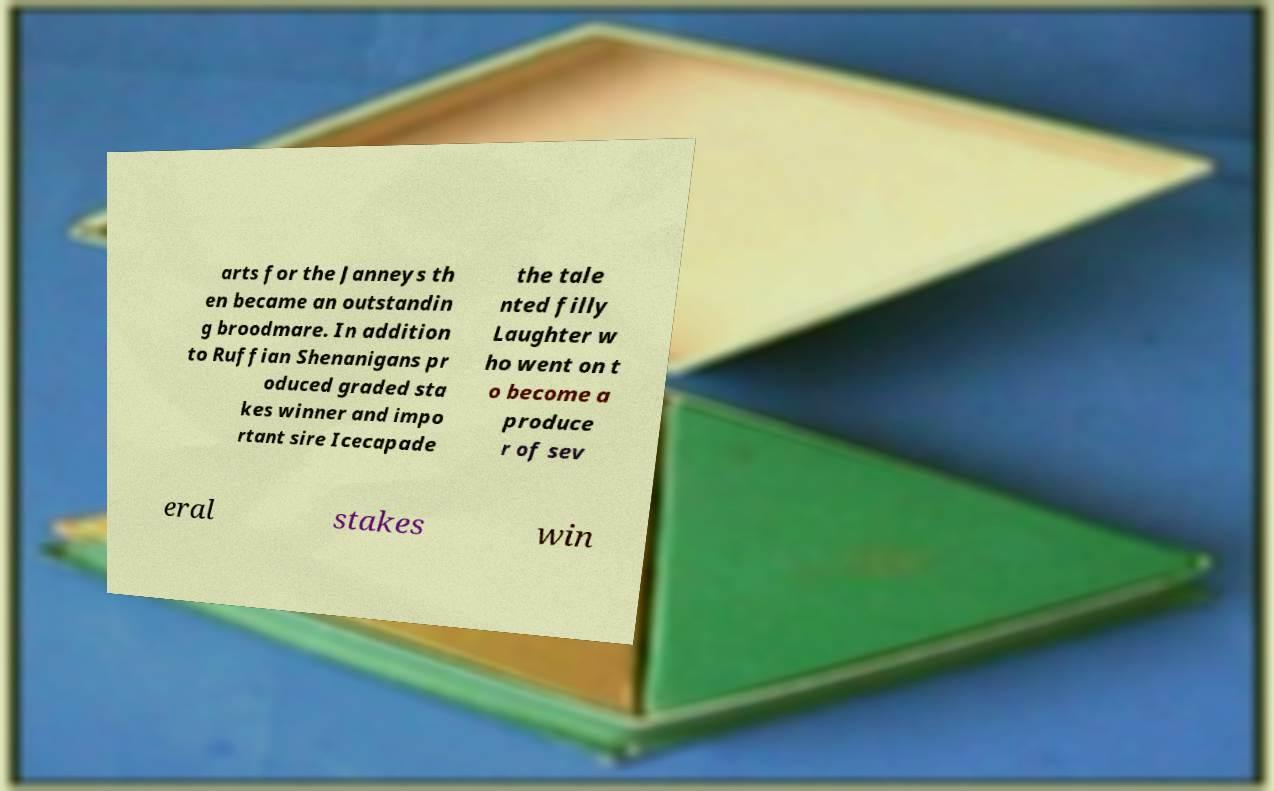What messages or text are displayed in this image? I need them in a readable, typed format. arts for the Janneys th en became an outstandin g broodmare. In addition to Ruffian Shenanigans pr oduced graded sta kes winner and impo rtant sire Icecapade the tale nted filly Laughter w ho went on t o become a produce r of sev eral stakes win 